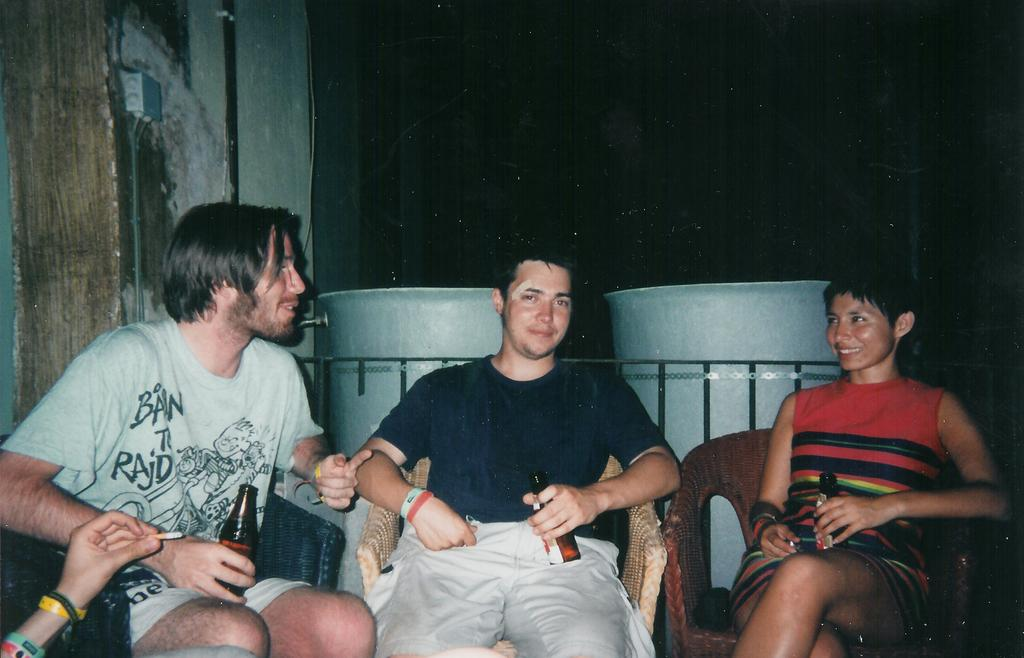What are the people in the image doing? The people in the image are sitting on chairs. What are the people holding in their hands? The people are holding bottles. How can you describe the attire of the people in the image? The people are wearing different color dresses. What can be seen in the background of the image? There is a dark background in the image. What color is the wall visible in the image? There is a green wall visible in the image. What type of stem can be seen on the bottles in the image? There is no stem visible on the bottles in the image. What kind of stamp is present on the dresses of the people in the image? There are no stamps visible on the dresses of the people in the image. 